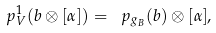Convert formula to latex. <formula><loc_0><loc_0><loc_500><loc_500>\ p ^ { 1 } _ { V } ( b \otimes [ \alpha ] ) = \ p _ { g _ { B } } ( b ) \otimes [ \alpha ] ,</formula> 